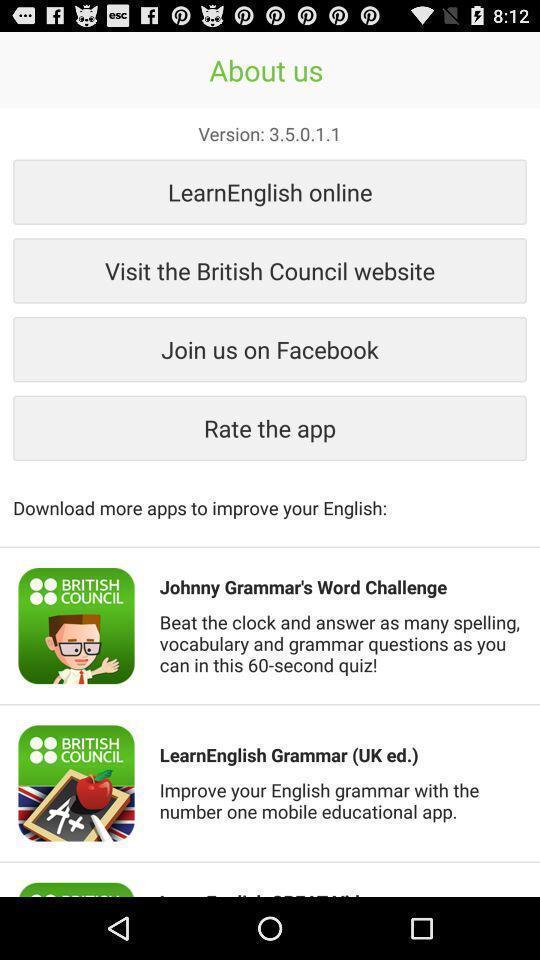Provide a detailed account of this screenshot. Page displaying the version. 